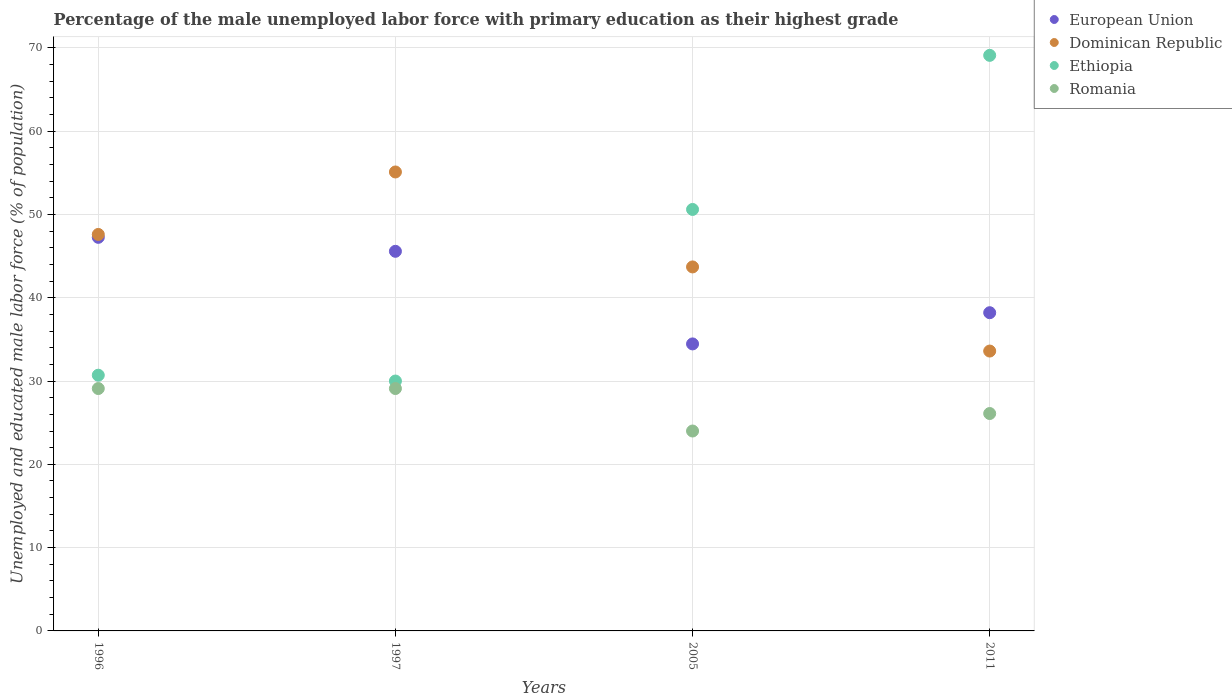How many different coloured dotlines are there?
Make the answer very short. 4. Is the number of dotlines equal to the number of legend labels?
Keep it short and to the point. Yes. What is the percentage of the unemployed male labor force with primary education in Romania in 1997?
Provide a succinct answer. 29.1. Across all years, what is the maximum percentage of the unemployed male labor force with primary education in European Union?
Make the answer very short. 47.25. Across all years, what is the minimum percentage of the unemployed male labor force with primary education in European Union?
Ensure brevity in your answer.  34.46. In which year was the percentage of the unemployed male labor force with primary education in Dominican Republic maximum?
Make the answer very short. 1997. What is the total percentage of the unemployed male labor force with primary education in European Union in the graph?
Ensure brevity in your answer.  165.49. What is the difference between the percentage of the unemployed male labor force with primary education in Romania in 1996 and that in 1997?
Provide a short and direct response. 0. What is the difference between the percentage of the unemployed male labor force with primary education in Ethiopia in 2011 and the percentage of the unemployed male labor force with primary education in Romania in 1996?
Provide a short and direct response. 40. What is the average percentage of the unemployed male labor force with primary education in Dominican Republic per year?
Keep it short and to the point. 45. In the year 1997, what is the difference between the percentage of the unemployed male labor force with primary education in European Union and percentage of the unemployed male labor force with primary education in Dominican Republic?
Your response must be concise. -9.52. What is the ratio of the percentage of the unemployed male labor force with primary education in Dominican Republic in 1997 to that in 2005?
Your answer should be very brief. 1.26. Is the percentage of the unemployed male labor force with primary education in Ethiopia in 1996 less than that in 1997?
Offer a very short reply. No. Is the difference between the percentage of the unemployed male labor force with primary education in European Union in 1997 and 2011 greater than the difference between the percentage of the unemployed male labor force with primary education in Dominican Republic in 1997 and 2011?
Make the answer very short. No. What is the difference between the highest and the second highest percentage of the unemployed male labor force with primary education in Ethiopia?
Your response must be concise. 18.5. Is it the case that in every year, the sum of the percentage of the unemployed male labor force with primary education in Dominican Republic and percentage of the unemployed male labor force with primary education in Romania  is greater than the sum of percentage of the unemployed male labor force with primary education in Ethiopia and percentage of the unemployed male labor force with primary education in European Union?
Your answer should be very brief. No. Is it the case that in every year, the sum of the percentage of the unemployed male labor force with primary education in European Union and percentage of the unemployed male labor force with primary education in Ethiopia  is greater than the percentage of the unemployed male labor force with primary education in Dominican Republic?
Ensure brevity in your answer.  Yes. How many dotlines are there?
Provide a short and direct response. 4. How many years are there in the graph?
Give a very brief answer. 4. Does the graph contain any zero values?
Give a very brief answer. No. How many legend labels are there?
Your answer should be very brief. 4. How are the legend labels stacked?
Your response must be concise. Vertical. What is the title of the graph?
Ensure brevity in your answer.  Percentage of the male unemployed labor force with primary education as their highest grade. What is the label or title of the X-axis?
Provide a succinct answer. Years. What is the label or title of the Y-axis?
Your response must be concise. Unemployed and educated male labor force (% of population). What is the Unemployed and educated male labor force (% of population) in European Union in 1996?
Offer a very short reply. 47.25. What is the Unemployed and educated male labor force (% of population) of Dominican Republic in 1996?
Give a very brief answer. 47.6. What is the Unemployed and educated male labor force (% of population) of Ethiopia in 1996?
Ensure brevity in your answer.  30.7. What is the Unemployed and educated male labor force (% of population) in Romania in 1996?
Make the answer very short. 29.1. What is the Unemployed and educated male labor force (% of population) of European Union in 1997?
Your answer should be compact. 45.58. What is the Unemployed and educated male labor force (% of population) in Dominican Republic in 1997?
Offer a terse response. 55.1. What is the Unemployed and educated male labor force (% of population) in Ethiopia in 1997?
Give a very brief answer. 30. What is the Unemployed and educated male labor force (% of population) in Romania in 1997?
Give a very brief answer. 29.1. What is the Unemployed and educated male labor force (% of population) in European Union in 2005?
Your answer should be compact. 34.46. What is the Unemployed and educated male labor force (% of population) in Dominican Republic in 2005?
Your response must be concise. 43.7. What is the Unemployed and educated male labor force (% of population) of Ethiopia in 2005?
Give a very brief answer. 50.6. What is the Unemployed and educated male labor force (% of population) of Romania in 2005?
Offer a terse response. 24. What is the Unemployed and educated male labor force (% of population) in European Union in 2011?
Your answer should be very brief. 38.2. What is the Unemployed and educated male labor force (% of population) in Dominican Republic in 2011?
Ensure brevity in your answer.  33.6. What is the Unemployed and educated male labor force (% of population) in Ethiopia in 2011?
Ensure brevity in your answer.  69.1. What is the Unemployed and educated male labor force (% of population) in Romania in 2011?
Offer a terse response. 26.1. Across all years, what is the maximum Unemployed and educated male labor force (% of population) of European Union?
Your response must be concise. 47.25. Across all years, what is the maximum Unemployed and educated male labor force (% of population) in Dominican Republic?
Offer a very short reply. 55.1. Across all years, what is the maximum Unemployed and educated male labor force (% of population) in Ethiopia?
Give a very brief answer. 69.1. Across all years, what is the maximum Unemployed and educated male labor force (% of population) in Romania?
Provide a succinct answer. 29.1. Across all years, what is the minimum Unemployed and educated male labor force (% of population) in European Union?
Make the answer very short. 34.46. Across all years, what is the minimum Unemployed and educated male labor force (% of population) in Dominican Republic?
Your answer should be compact. 33.6. Across all years, what is the minimum Unemployed and educated male labor force (% of population) in Romania?
Give a very brief answer. 24. What is the total Unemployed and educated male labor force (% of population) in European Union in the graph?
Your answer should be very brief. 165.49. What is the total Unemployed and educated male labor force (% of population) of Dominican Republic in the graph?
Your answer should be very brief. 180. What is the total Unemployed and educated male labor force (% of population) in Ethiopia in the graph?
Offer a terse response. 180.4. What is the total Unemployed and educated male labor force (% of population) of Romania in the graph?
Keep it short and to the point. 108.3. What is the difference between the Unemployed and educated male labor force (% of population) in European Union in 1996 and that in 1997?
Provide a short and direct response. 1.68. What is the difference between the Unemployed and educated male labor force (% of population) in Dominican Republic in 1996 and that in 1997?
Ensure brevity in your answer.  -7.5. What is the difference between the Unemployed and educated male labor force (% of population) in Romania in 1996 and that in 1997?
Your response must be concise. 0. What is the difference between the Unemployed and educated male labor force (% of population) in European Union in 1996 and that in 2005?
Ensure brevity in your answer.  12.8. What is the difference between the Unemployed and educated male labor force (% of population) in Ethiopia in 1996 and that in 2005?
Keep it short and to the point. -19.9. What is the difference between the Unemployed and educated male labor force (% of population) in European Union in 1996 and that in 2011?
Keep it short and to the point. 9.05. What is the difference between the Unemployed and educated male labor force (% of population) in Ethiopia in 1996 and that in 2011?
Provide a short and direct response. -38.4. What is the difference between the Unemployed and educated male labor force (% of population) of European Union in 1997 and that in 2005?
Your response must be concise. 11.12. What is the difference between the Unemployed and educated male labor force (% of population) in Dominican Republic in 1997 and that in 2005?
Your response must be concise. 11.4. What is the difference between the Unemployed and educated male labor force (% of population) of Ethiopia in 1997 and that in 2005?
Keep it short and to the point. -20.6. What is the difference between the Unemployed and educated male labor force (% of population) of European Union in 1997 and that in 2011?
Make the answer very short. 7.37. What is the difference between the Unemployed and educated male labor force (% of population) of Dominican Republic in 1997 and that in 2011?
Provide a short and direct response. 21.5. What is the difference between the Unemployed and educated male labor force (% of population) in Ethiopia in 1997 and that in 2011?
Your answer should be compact. -39.1. What is the difference between the Unemployed and educated male labor force (% of population) in European Union in 2005 and that in 2011?
Your response must be concise. -3.75. What is the difference between the Unemployed and educated male labor force (% of population) of Dominican Republic in 2005 and that in 2011?
Give a very brief answer. 10.1. What is the difference between the Unemployed and educated male labor force (% of population) in Ethiopia in 2005 and that in 2011?
Provide a succinct answer. -18.5. What is the difference between the Unemployed and educated male labor force (% of population) in Romania in 2005 and that in 2011?
Ensure brevity in your answer.  -2.1. What is the difference between the Unemployed and educated male labor force (% of population) in European Union in 1996 and the Unemployed and educated male labor force (% of population) in Dominican Republic in 1997?
Offer a terse response. -7.85. What is the difference between the Unemployed and educated male labor force (% of population) in European Union in 1996 and the Unemployed and educated male labor force (% of population) in Ethiopia in 1997?
Your answer should be very brief. 17.25. What is the difference between the Unemployed and educated male labor force (% of population) in European Union in 1996 and the Unemployed and educated male labor force (% of population) in Romania in 1997?
Your response must be concise. 18.15. What is the difference between the Unemployed and educated male labor force (% of population) in Dominican Republic in 1996 and the Unemployed and educated male labor force (% of population) in Ethiopia in 1997?
Ensure brevity in your answer.  17.6. What is the difference between the Unemployed and educated male labor force (% of population) in Dominican Republic in 1996 and the Unemployed and educated male labor force (% of population) in Romania in 1997?
Your response must be concise. 18.5. What is the difference between the Unemployed and educated male labor force (% of population) in Ethiopia in 1996 and the Unemployed and educated male labor force (% of population) in Romania in 1997?
Your answer should be compact. 1.6. What is the difference between the Unemployed and educated male labor force (% of population) of European Union in 1996 and the Unemployed and educated male labor force (% of population) of Dominican Republic in 2005?
Make the answer very short. 3.55. What is the difference between the Unemployed and educated male labor force (% of population) in European Union in 1996 and the Unemployed and educated male labor force (% of population) in Ethiopia in 2005?
Keep it short and to the point. -3.35. What is the difference between the Unemployed and educated male labor force (% of population) in European Union in 1996 and the Unemployed and educated male labor force (% of population) in Romania in 2005?
Make the answer very short. 23.25. What is the difference between the Unemployed and educated male labor force (% of population) in Dominican Republic in 1996 and the Unemployed and educated male labor force (% of population) in Romania in 2005?
Your answer should be compact. 23.6. What is the difference between the Unemployed and educated male labor force (% of population) of European Union in 1996 and the Unemployed and educated male labor force (% of population) of Dominican Republic in 2011?
Give a very brief answer. 13.65. What is the difference between the Unemployed and educated male labor force (% of population) in European Union in 1996 and the Unemployed and educated male labor force (% of population) in Ethiopia in 2011?
Your answer should be compact. -21.85. What is the difference between the Unemployed and educated male labor force (% of population) in European Union in 1996 and the Unemployed and educated male labor force (% of population) in Romania in 2011?
Give a very brief answer. 21.15. What is the difference between the Unemployed and educated male labor force (% of population) in Dominican Republic in 1996 and the Unemployed and educated male labor force (% of population) in Ethiopia in 2011?
Your answer should be compact. -21.5. What is the difference between the Unemployed and educated male labor force (% of population) of European Union in 1997 and the Unemployed and educated male labor force (% of population) of Dominican Republic in 2005?
Provide a short and direct response. 1.88. What is the difference between the Unemployed and educated male labor force (% of population) in European Union in 1997 and the Unemployed and educated male labor force (% of population) in Ethiopia in 2005?
Make the answer very short. -5.02. What is the difference between the Unemployed and educated male labor force (% of population) of European Union in 1997 and the Unemployed and educated male labor force (% of population) of Romania in 2005?
Offer a terse response. 21.58. What is the difference between the Unemployed and educated male labor force (% of population) of Dominican Republic in 1997 and the Unemployed and educated male labor force (% of population) of Romania in 2005?
Offer a very short reply. 31.1. What is the difference between the Unemployed and educated male labor force (% of population) in Ethiopia in 1997 and the Unemployed and educated male labor force (% of population) in Romania in 2005?
Make the answer very short. 6. What is the difference between the Unemployed and educated male labor force (% of population) in European Union in 1997 and the Unemployed and educated male labor force (% of population) in Dominican Republic in 2011?
Offer a terse response. 11.98. What is the difference between the Unemployed and educated male labor force (% of population) in European Union in 1997 and the Unemployed and educated male labor force (% of population) in Ethiopia in 2011?
Your answer should be very brief. -23.52. What is the difference between the Unemployed and educated male labor force (% of population) in European Union in 1997 and the Unemployed and educated male labor force (% of population) in Romania in 2011?
Make the answer very short. 19.48. What is the difference between the Unemployed and educated male labor force (% of population) of Ethiopia in 1997 and the Unemployed and educated male labor force (% of population) of Romania in 2011?
Ensure brevity in your answer.  3.9. What is the difference between the Unemployed and educated male labor force (% of population) of European Union in 2005 and the Unemployed and educated male labor force (% of population) of Dominican Republic in 2011?
Make the answer very short. 0.86. What is the difference between the Unemployed and educated male labor force (% of population) of European Union in 2005 and the Unemployed and educated male labor force (% of population) of Ethiopia in 2011?
Your response must be concise. -34.64. What is the difference between the Unemployed and educated male labor force (% of population) of European Union in 2005 and the Unemployed and educated male labor force (% of population) of Romania in 2011?
Keep it short and to the point. 8.36. What is the difference between the Unemployed and educated male labor force (% of population) of Dominican Republic in 2005 and the Unemployed and educated male labor force (% of population) of Ethiopia in 2011?
Your response must be concise. -25.4. What is the difference between the Unemployed and educated male labor force (% of population) in Ethiopia in 2005 and the Unemployed and educated male labor force (% of population) in Romania in 2011?
Make the answer very short. 24.5. What is the average Unemployed and educated male labor force (% of population) in European Union per year?
Keep it short and to the point. 41.37. What is the average Unemployed and educated male labor force (% of population) of Dominican Republic per year?
Your answer should be compact. 45. What is the average Unemployed and educated male labor force (% of population) of Ethiopia per year?
Keep it short and to the point. 45.1. What is the average Unemployed and educated male labor force (% of population) of Romania per year?
Provide a succinct answer. 27.07. In the year 1996, what is the difference between the Unemployed and educated male labor force (% of population) in European Union and Unemployed and educated male labor force (% of population) in Dominican Republic?
Ensure brevity in your answer.  -0.35. In the year 1996, what is the difference between the Unemployed and educated male labor force (% of population) in European Union and Unemployed and educated male labor force (% of population) in Ethiopia?
Provide a succinct answer. 16.55. In the year 1996, what is the difference between the Unemployed and educated male labor force (% of population) of European Union and Unemployed and educated male labor force (% of population) of Romania?
Your answer should be compact. 18.15. In the year 1997, what is the difference between the Unemployed and educated male labor force (% of population) of European Union and Unemployed and educated male labor force (% of population) of Dominican Republic?
Your answer should be very brief. -9.52. In the year 1997, what is the difference between the Unemployed and educated male labor force (% of population) in European Union and Unemployed and educated male labor force (% of population) in Ethiopia?
Provide a short and direct response. 15.58. In the year 1997, what is the difference between the Unemployed and educated male labor force (% of population) in European Union and Unemployed and educated male labor force (% of population) in Romania?
Offer a very short reply. 16.48. In the year 1997, what is the difference between the Unemployed and educated male labor force (% of population) in Dominican Republic and Unemployed and educated male labor force (% of population) in Ethiopia?
Your answer should be very brief. 25.1. In the year 1997, what is the difference between the Unemployed and educated male labor force (% of population) in Dominican Republic and Unemployed and educated male labor force (% of population) in Romania?
Ensure brevity in your answer.  26. In the year 2005, what is the difference between the Unemployed and educated male labor force (% of population) of European Union and Unemployed and educated male labor force (% of population) of Dominican Republic?
Provide a short and direct response. -9.24. In the year 2005, what is the difference between the Unemployed and educated male labor force (% of population) of European Union and Unemployed and educated male labor force (% of population) of Ethiopia?
Your answer should be compact. -16.14. In the year 2005, what is the difference between the Unemployed and educated male labor force (% of population) in European Union and Unemployed and educated male labor force (% of population) in Romania?
Ensure brevity in your answer.  10.46. In the year 2005, what is the difference between the Unemployed and educated male labor force (% of population) of Ethiopia and Unemployed and educated male labor force (% of population) of Romania?
Provide a short and direct response. 26.6. In the year 2011, what is the difference between the Unemployed and educated male labor force (% of population) of European Union and Unemployed and educated male labor force (% of population) of Dominican Republic?
Your answer should be compact. 4.6. In the year 2011, what is the difference between the Unemployed and educated male labor force (% of population) in European Union and Unemployed and educated male labor force (% of population) in Ethiopia?
Give a very brief answer. -30.9. In the year 2011, what is the difference between the Unemployed and educated male labor force (% of population) of European Union and Unemployed and educated male labor force (% of population) of Romania?
Ensure brevity in your answer.  12.1. In the year 2011, what is the difference between the Unemployed and educated male labor force (% of population) in Dominican Republic and Unemployed and educated male labor force (% of population) in Ethiopia?
Ensure brevity in your answer.  -35.5. In the year 2011, what is the difference between the Unemployed and educated male labor force (% of population) in Dominican Republic and Unemployed and educated male labor force (% of population) in Romania?
Your answer should be compact. 7.5. What is the ratio of the Unemployed and educated male labor force (% of population) of European Union in 1996 to that in 1997?
Your answer should be very brief. 1.04. What is the ratio of the Unemployed and educated male labor force (% of population) of Dominican Republic in 1996 to that in 1997?
Offer a very short reply. 0.86. What is the ratio of the Unemployed and educated male labor force (% of population) of Ethiopia in 1996 to that in 1997?
Give a very brief answer. 1.02. What is the ratio of the Unemployed and educated male labor force (% of population) in European Union in 1996 to that in 2005?
Offer a very short reply. 1.37. What is the ratio of the Unemployed and educated male labor force (% of population) in Dominican Republic in 1996 to that in 2005?
Make the answer very short. 1.09. What is the ratio of the Unemployed and educated male labor force (% of population) in Ethiopia in 1996 to that in 2005?
Offer a very short reply. 0.61. What is the ratio of the Unemployed and educated male labor force (% of population) of Romania in 1996 to that in 2005?
Your response must be concise. 1.21. What is the ratio of the Unemployed and educated male labor force (% of population) in European Union in 1996 to that in 2011?
Your answer should be compact. 1.24. What is the ratio of the Unemployed and educated male labor force (% of population) in Dominican Republic in 1996 to that in 2011?
Make the answer very short. 1.42. What is the ratio of the Unemployed and educated male labor force (% of population) of Ethiopia in 1996 to that in 2011?
Make the answer very short. 0.44. What is the ratio of the Unemployed and educated male labor force (% of population) of Romania in 1996 to that in 2011?
Offer a very short reply. 1.11. What is the ratio of the Unemployed and educated male labor force (% of population) in European Union in 1997 to that in 2005?
Make the answer very short. 1.32. What is the ratio of the Unemployed and educated male labor force (% of population) in Dominican Republic in 1997 to that in 2005?
Keep it short and to the point. 1.26. What is the ratio of the Unemployed and educated male labor force (% of population) in Ethiopia in 1997 to that in 2005?
Keep it short and to the point. 0.59. What is the ratio of the Unemployed and educated male labor force (% of population) in Romania in 1997 to that in 2005?
Give a very brief answer. 1.21. What is the ratio of the Unemployed and educated male labor force (% of population) of European Union in 1997 to that in 2011?
Your response must be concise. 1.19. What is the ratio of the Unemployed and educated male labor force (% of population) in Dominican Republic in 1997 to that in 2011?
Offer a terse response. 1.64. What is the ratio of the Unemployed and educated male labor force (% of population) in Ethiopia in 1997 to that in 2011?
Keep it short and to the point. 0.43. What is the ratio of the Unemployed and educated male labor force (% of population) in Romania in 1997 to that in 2011?
Make the answer very short. 1.11. What is the ratio of the Unemployed and educated male labor force (% of population) of European Union in 2005 to that in 2011?
Your response must be concise. 0.9. What is the ratio of the Unemployed and educated male labor force (% of population) of Dominican Republic in 2005 to that in 2011?
Make the answer very short. 1.3. What is the ratio of the Unemployed and educated male labor force (% of population) in Ethiopia in 2005 to that in 2011?
Your answer should be very brief. 0.73. What is the ratio of the Unemployed and educated male labor force (% of population) in Romania in 2005 to that in 2011?
Offer a terse response. 0.92. What is the difference between the highest and the second highest Unemployed and educated male labor force (% of population) in European Union?
Your answer should be compact. 1.68. What is the difference between the highest and the second highest Unemployed and educated male labor force (% of population) of Dominican Republic?
Keep it short and to the point. 7.5. What is the difference between the highest and the lowest Unemployed and educated male labor force (% of population) in European Union?
Provide a succinct answer. 12.8. What is the difference between the highest and the lowest Unemployed and educated male labor force (% of population) in Ethiopia?
Ensure brevity in your answer.  39.1. What is the difference between the highest and the lowest Unemployed and educated male labor force (% of population) of Romania?
Ensure brevity in your answer.  5.1. 